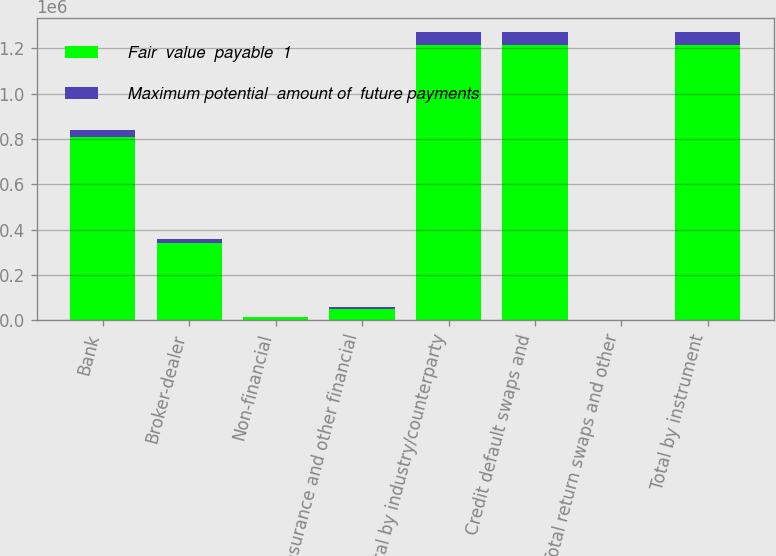Convert chart to OTSL. <chart><loc_0><loc_0><loc_500><loc_500><stacked_bar_chart><ecel><fcel>Bank<fcel>Broker-dealer<fcel>Non-financial<fcel>Insurance and other financial<fcel>Total by industry/counterparty<fcel>Credit default swaps and<fcel>Total return swaps and other<fcel>Total by instrument<nl><fcel>Fair  value  payable  1<fcel>807484<fcel>340949<fcel>13221<fcel>52366<fcel>1.21405e+06<fcel>1.21321e+06<fcel>845<fcel>1.21405e+06<nl><fcel>Maximum potential  amount of  future payments<fcel>34666<fcel>16309<fcel>262<fcel>7025<fcel>58262<fcel>57987<fcel>275<fcel>58262<nl></chart> 